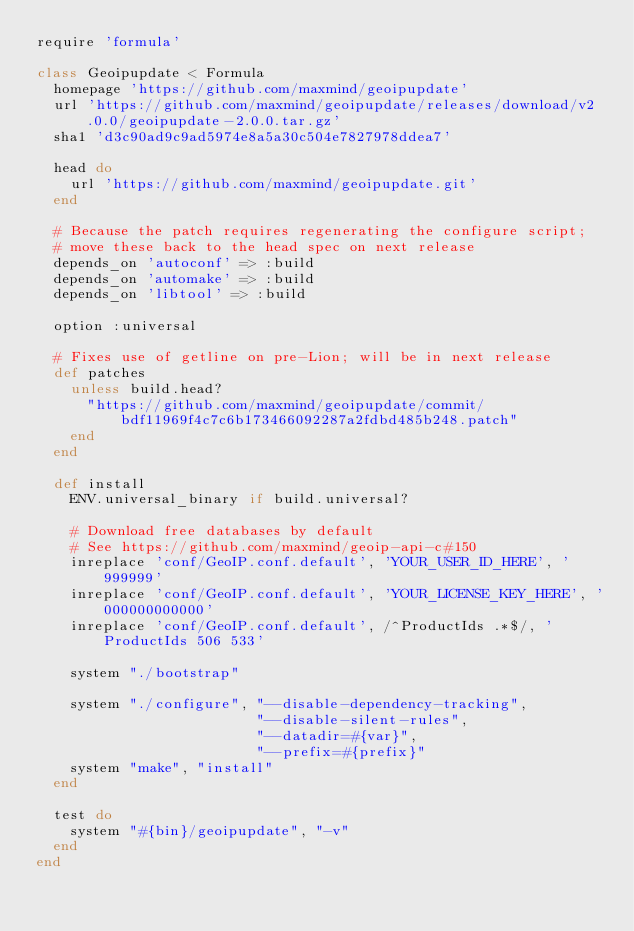<code> <loc_0><loc_0><loc_500><loc_500><_Ruby_>require 'formula'

class Geoipupdate < Formula
  homepage 'https://github.com/maxmind/geoipupdate'
  url 'https://github.com/maxmind/geoipupdate/releases/download/v2.0.0/geoipupdate-2.0.0.tar.gz'
  sha1 'd3c90ad9c9ad5974e8a5a30c504e7827978ddea7'

  head do
    url 'https://github.com/maxmind/geoipupdate.git'
  end

  # Because the patch requires regenerating the configure script;
  # move these back to the head spec on next release
  depends_on 'autoconf' => :build
  depends_on 'automake' => :build
  depends_on 'libtool' => :build

  option :universal

  # Fixes use of getline on pre-Lion; will be in next release
  def patches
    unless build.head?
      "https://github.com/maxmind/geoipupdate/commit/bdf11969f4c7c6b173466092287a2fdbd485b248.patch"
    end
  end

  def install
    ENV.universal_binary if build.universal?

    # Download free databases by default
    # See https://github.com/maxmind/geoip-api-c#150
    inreplace 'conf/GeoIP.conf.default', 'YOUR_USER_ID_HERE', '999999'
    inreplace 'conf/GeoIP.conf.default', 'YOUR_LICENSE_KEY_HERE', '000000000000'
    inreplace 'conf/GeoIP.conf.default', /^ProductIds .*$/, 'ProductIds 506 533'

    system "./bootstrap"

    system "./configure", "--disable-dependency-tracking",
                          "--disable-silent-rules",
                          "--datadir=#{var}",
                          "--prefix=#{prefix}"
    system "make", "install"
  end

  test do
    system "#{bin}/geoipupdate", "-v"
  end
end
</code> 